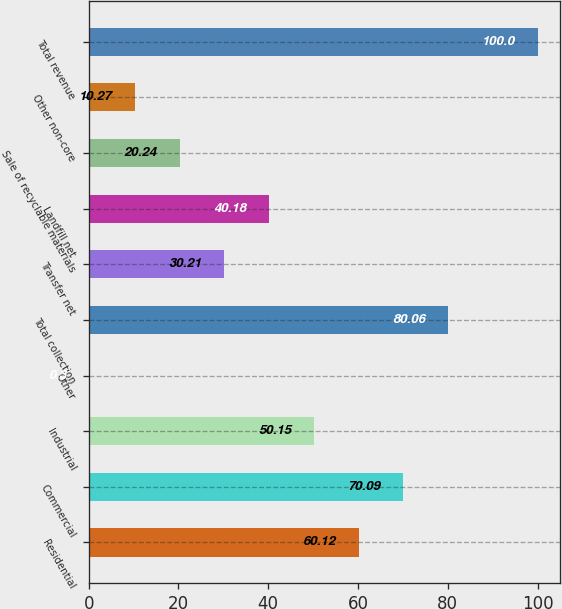Convert chart. <chart><loc_0><loc_0><loc_500><loc_500><bar_chart><fcel>Residential<fcel>Commercial<fcel>Industrial<fcel>Other<fcel>Total collection<fcel>Transfer net<fcel>Landfill net<fcel>Sale of recyclable materials<fcel>Other non-core<fcel>Total revenue<nl><fcel>60.12<fcel>70.09<fcel>50.15<fcel>0.3<fcel>80.06<fcel>30.21<fcel>40.18<fcel>20.24<fcel>10.27<fcel>100<nl></chart> 